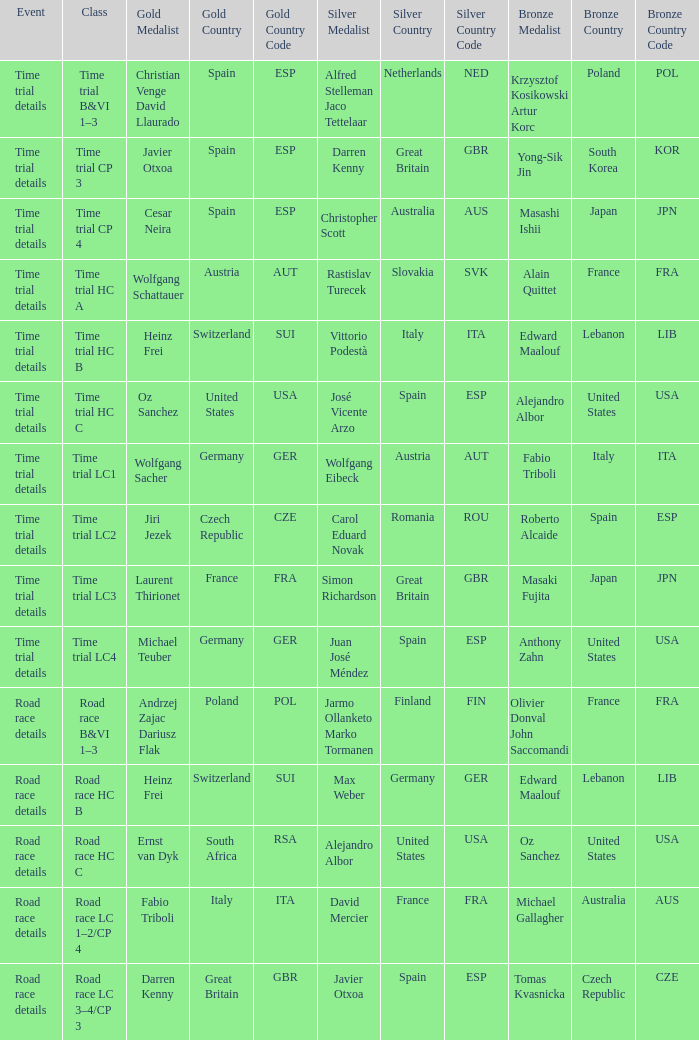Would you be able to parse every entry in this table? {'header': ['Event', 'Class', 'Gold Medalist', 'Gold Country', 'Gold Country Code', 'Silver Medalist', 'Silver Country', 'Silver Country Code', 'Bronze Medalist', 'Bronze Country', 'Bronze Country Code'], 'rows': [['Time trial details', 'Time trial B&VI 1–3', 'Christian Venge David Llaurado', 'Spain', 'ESP', 'Alfred Stelleman Jaco Tettelaar', 'Netherlands', 'NED', 'Krzysztof Kosikowski Artur Korc', 'Poland', 'POL'], ['Time trial details', 'Time trial CP 3', 'Javier Otxoa', 'Spain', 'ESP', 'Darren Kenny', 'Great Britain', 'GBR', 'Yong-Sik Jin', 'South Korea', 'KOR'], ['Time trial details', 'Time trial CP 4', 'Cesar Neira', 'Spain', 'ESP', 'Christopher Scott', 'Australia', 'AUS', 'Masashi Ishii', 'Japan', 'JPN'], ['Time trial details', 'Time trial HC A', 'Wolfgang Schattauer', 'Austria', 'AUT', 'Rastislav Turecek', 'Slovakia', 'SVK', 'Alain Quittet', 'France', 'FRA'], ['Time trial details', 'Time trial HC B', 'Heinz Frei', 'Switzerland', 'SUI', 'Vittorio Podestà', 'Italy', 'ITA', 'Edward Maalouf', 'Lebanon', 'LIB'], ['Time trial details', 'Time trial HC C', 'Oz Sanchez', 'United States', 'USA', 'José Vicente Arzo', 'Spain', 'ESP', 'Alejandro Albor', 'United States', 'USA'], ['Time trial details', 'Time trial LC1', 'Wolfgang Sacher', 'Germany', 'GER', 'Wolfgang Eibeck', 'Austria', 'AUT', 'Fabio Triboli', 'Italy', 'ITA'], ['Time trial details', 'Time trial LC2', 'Jiri Jezek', 'Czech Republic', 'CZE', 'Carol Eduard Novak', 'Romania', 'ROU', 'Roberto Alcaide', 'Spain', 'ESP'], ['Time trial details', 'Time trial LC3', 'Laurent Thirionet', 'France', 'FRA', 'Simon Richardson', 'Great Britain', 'GBR', 'Masaki Fujita', 'Japan', 'JPN'], ['Time trial details', 'Time trial LC4', 'Michael Teuber', 'Germany', 'GER', 'Juan José Méndez', 'Spain', 'ESP', 'Anthony Zahn', 'United States', 'USA'], ['Road race details', 'Road race B&VI 1–3', 'Andrzej Zajac Dariusz Flak', 'Poland', 'POL', 'Jarmo Ollanketo Marko Tormanen', 'Finland', 'FIN', 'Olivier Donval John Saccomandi', 'France', 'FRA'], ['Road race details', 'Road race HC B', 'Heinz Frei', 'Switzerland', 'SUI', 'Max Weber', 'Germany', 'GER', 'Edward Maalouf', 'Lebanon', 'LIB'], ['Road race details', 'Road race HC C', 'Ernst van Dyk', 'South Africa', 'RSA', 'Alejandro Albor', 'United States', 'USA', 'Oz Sanchez', 'United States', 'USA'], ['Road race details', 'Road race LC 1–2/CP 4', 'Fabio Triboli', 'Italy', 'ITA', 'David Mercier', 'France', 'FRA', 'Michael Gallagher', 'Australia', 'AUS'], ['Road race details', 'Road race LC 3–4/CP 3', 'Darren Kenny', 'Great Britain', 'GBR', 'Javier Otxoa', 'Spain', 'ESP', 'Tomas Kvasnicka', 'Czech Republic', 'CZE']]} Who was awarded gold when the happening is road race particulars and silver is max weber germany (ger)? Heinz Frei Switzerland (SUI). 